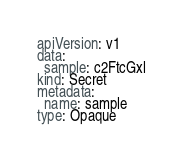Convert code to text. <code><loc_0><loc_0><loc_500><loc_500><_YAML_>apiVersion: v1
data:
  sample: c2FtcGxl
kind: Secret
metadata:
  name: sample
type: Opaque
</code> 